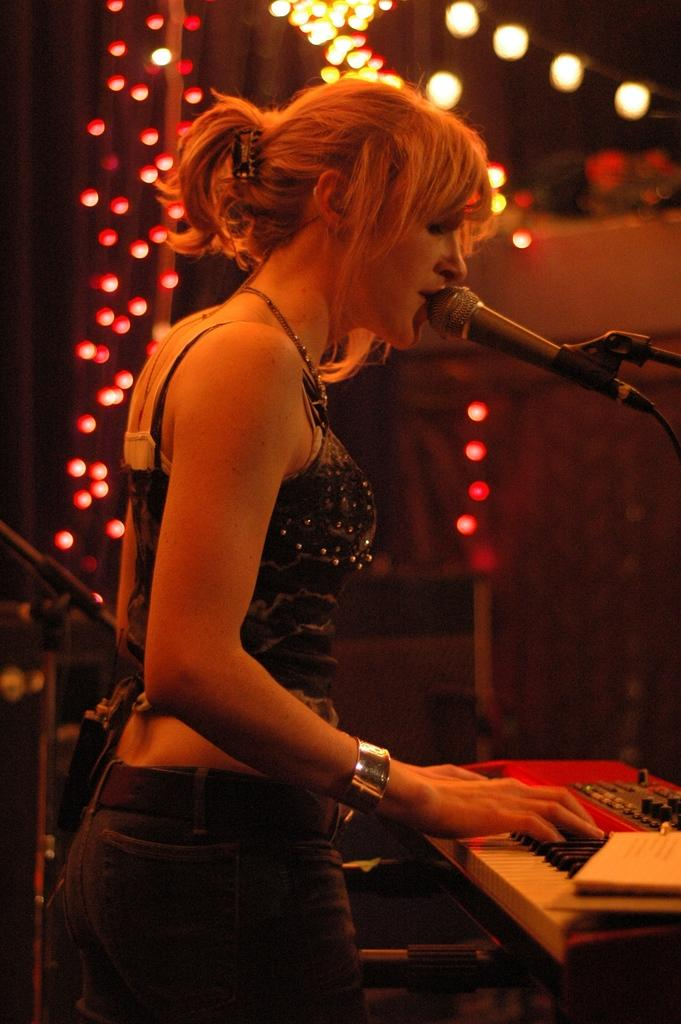Who is the main subject in the image? There is a lady in the image. What is the lady doing in the image? The lady is playing the guitar. What object is the lady standing in front of? The lady is in front of a microphone. What can be seen in the background of the image? There are lights visible in the image. What type of trouble can be seen in the bedroom in the image? There is no bedroom or trouble present in the image; it features a lady playing the guitar in front of a microphone with lights in the background. 